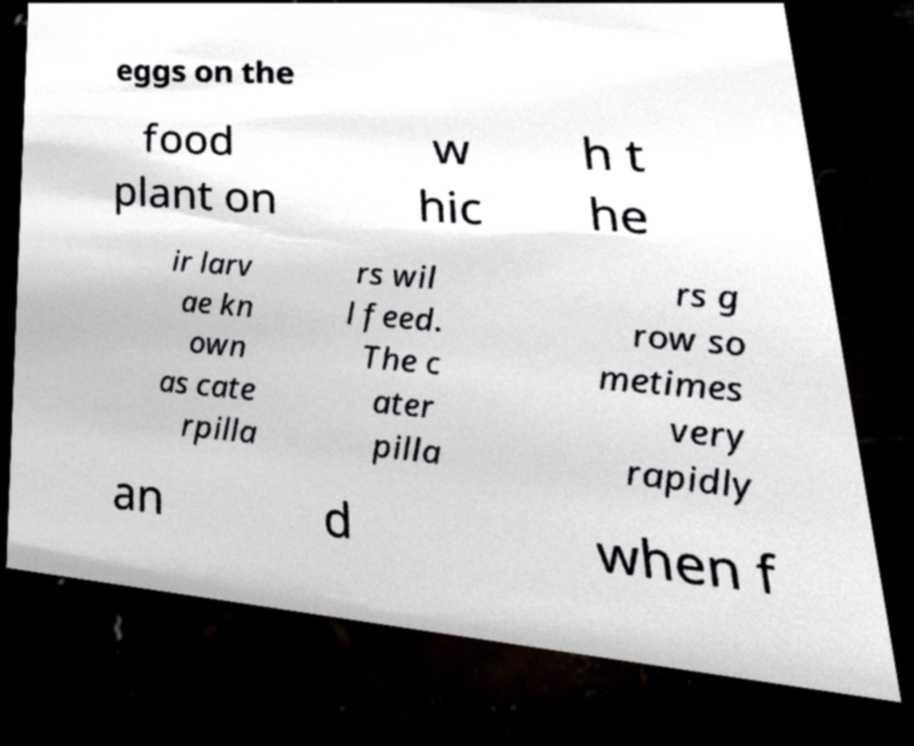Could you assist in decoding the text presented in this image and type it out clearly? eggs on the food plant on w hic h t he ir larv ae kn own as cate rpilla rs wil l feed. The c ater pilla rs g row so metimes very rapidly an d when f 